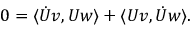Convert formula to latex. <formula><loc_0><loc_0><loc_500><loc_500>0 = \langle \ D o t { U } v , U w \rangle + \langle U v , \ D o t { U } w \rangle .</formula> 